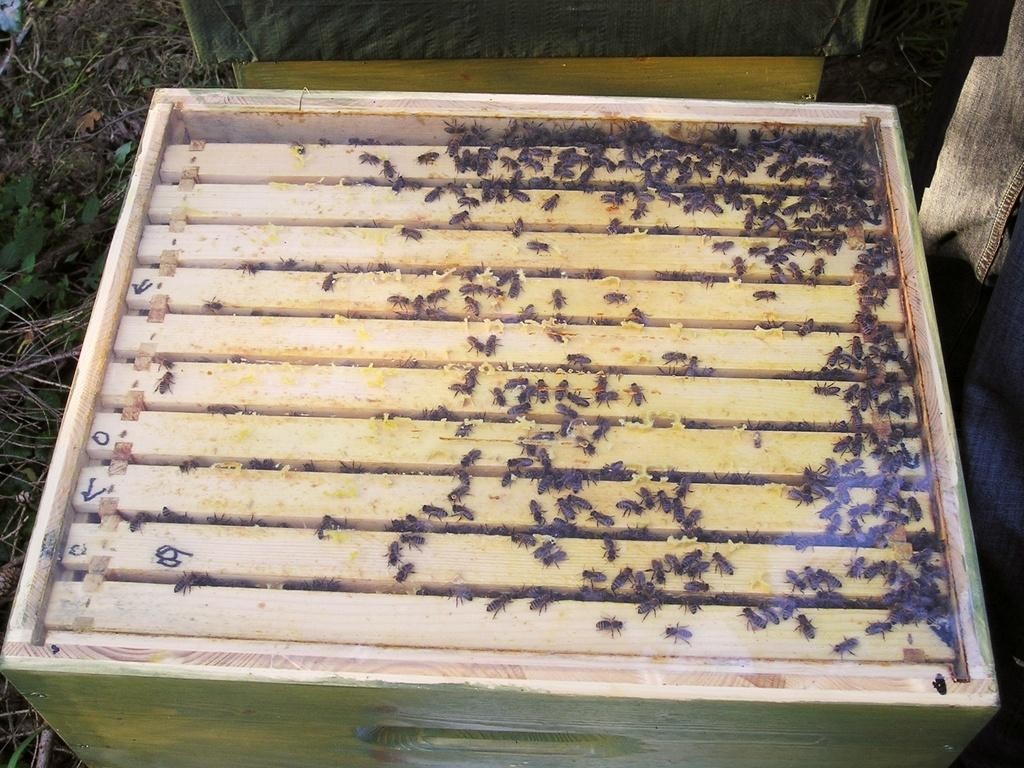What is on the box in the image? There are flies on a box in the image. What type of surface is visible in the image? There is grass on the surface in the image. How many lizards are laughing with heart-shaped eyes in the image? There are no lizards or heart-shaped eyes present in the image. 